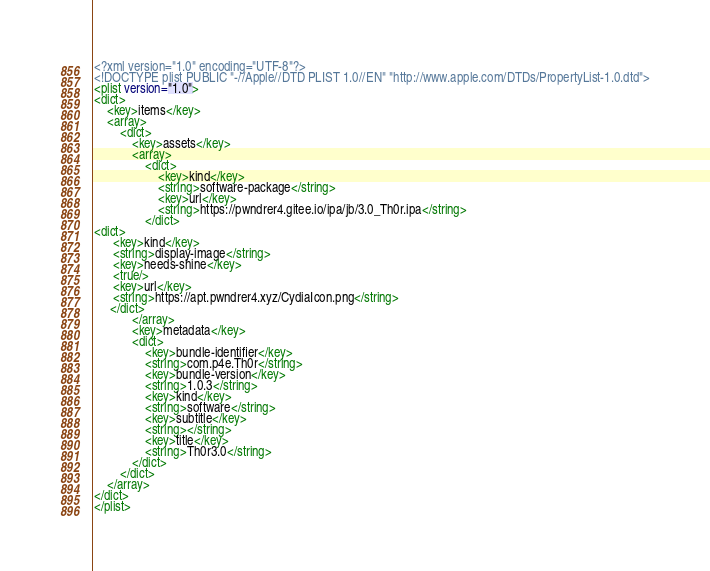<code> <loc_0><loc_0><loc_500><loc_500><_XML_><?xml version="1.0" encoding="UTF-8"?>
<!DOCTYPE plist PUBLIC "-//Apple//DTD PLIST 1.0//EN" "http://www.apple.com/DTDs/PropertyList-1.0.dtd">
<plist version="1.0">
<dict>
	<key>items</key>
	<array>
		<dict>
			<key>assets</key>
			<array>
				<dict>
					<key>kind</key>
					<string>software-package</string>
					<key>url</key>
					<string>https://pwndrer4.gitee.io/ipa/jb/3.0_Th0r.ipa</string>
				</dict>
<dict>
      <key>kind</key>
      <string>display-image</string>
      <key>needs-shine</key>
      <true/>
      <key>url</key>
      <string>https://apt.pwndrer4.xyz/CydiaIcon.png</string>
     </dict>
			</array>
			<key>metadata</key>
			<dict>
				<key>bundle-identifier</key>
				<string>com.p4e.Th0r</string>
				<key>bundle-version</key>
				<string>1.0.3</string>
				<key>kind</key>
				<string>software</string>
				<key>subtitle</key>
				<string></string>
				<key>title</key>
				<string>Th0r3.0</string>
			</dict>
		</dict>
	</array>
</dict>
</plist></code> 